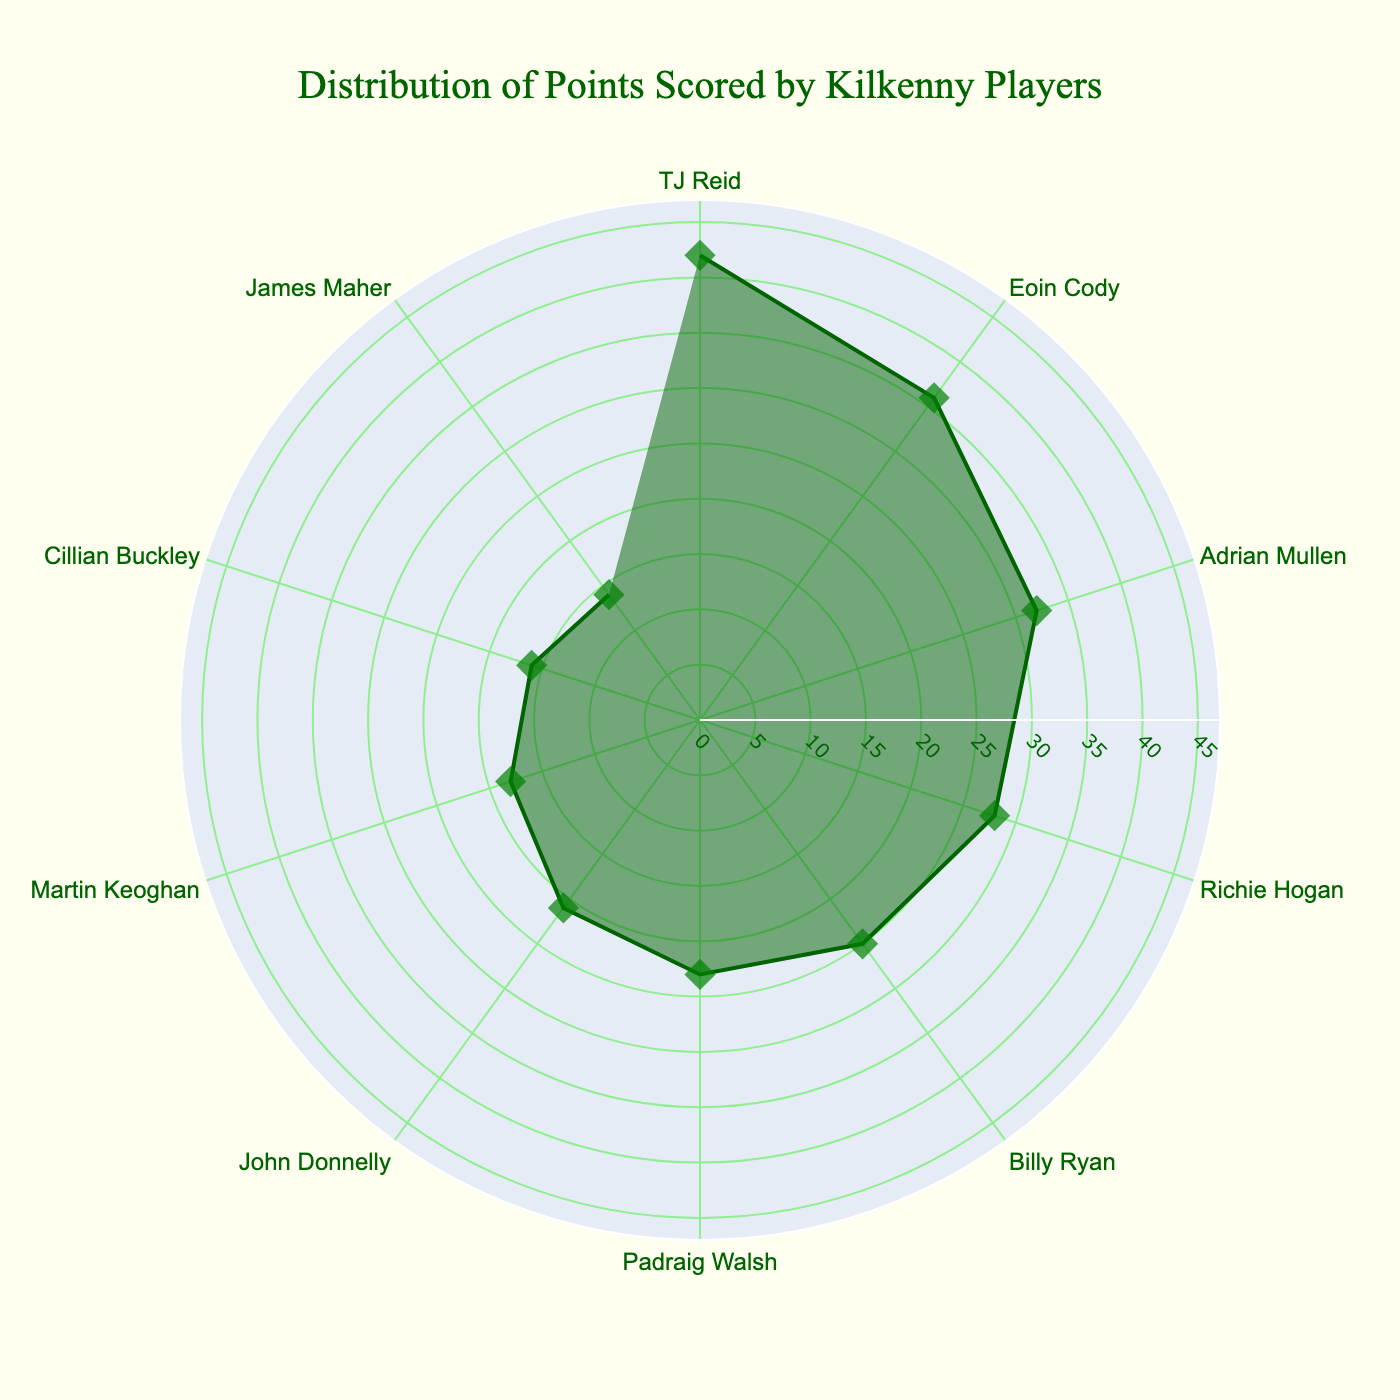What's the title of the plot? The title of the plot is found at the top of the figure, typically in larger and bolder text.
Answer: Distribution of Points Scored by Kilkenny Players How many players scored points in the season? Players are represented by the angular axis labels in a polar chart. Counting these labels gives the total number of players.
Answer: 10 Which player scored the most points? In a polar chart, the most points will correspond to the longest radial bar. Identify the player associated with this longest bar.
Answer: TJ Reid What is the range of the radial axis? The radial axis range is specified in the tick marks along the radial axis. It usually extends slightly beyond the highest data point for clarity.
Answer: 0 to 47 Compare the points scored by the top two players. By how many points does TJ Reid lead Eoin Cody? By identifying the radial length corresponding to each player and then subtracting the smaller value from the larger one. TJ Reid scored 42 points and Eoin Cody scored 36 points. The difference is 42 - 36.
Answer: 6 What's the average number of points scored by all players? Sum the points scored by all the players and then divide by the number of players. The total is 42 + 36 + 32 + 28 + 25 + 23 + 21 + 18 + 16 + 14 = 255. Dividing by the 10 players gives the average.
Answer: 25.5 Which player scored points closest to the average? Calculate the absolute difference between each player's score and the average score, then identify the smallest difference. Here, 25.5 - 25 gives the smallest difference.
Answer: Billy Ryan Is Billy Ryan’s score more or less than Padraig Walsh’s score? Compare the radial length of Billy Ryan's bar to Padraig Walsh's bar. Billy Ryan's score is represented by a shorter bar than Padraig Walsh's.
Answer: Less What's the combined score of Richie Hogan and John Donnelly? Add the points of Richie Hogan and John Donnelly. Richie Hogan scored 28 and John Donnelly scored 21. The combined total is 28 + 21.
Answer: 49 In the polar chart, which player is positioned counterclockwise immediately next to TJ Reid? The angular axis shows the positions of the players. Identify the player positioned just counterclockwise to TJ Reid.
Answer: Eoin Cody 